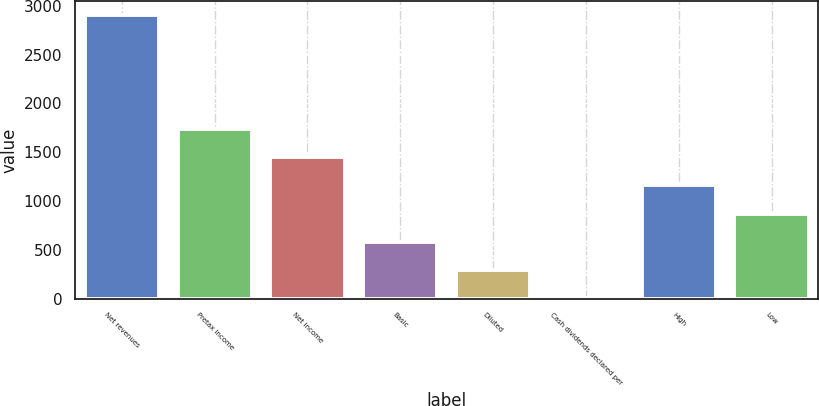Convert chart to OTSL. <chart><loc_0><loc_0><loc_500><loc_500><bar_chart><fcel>Net revenues<fcel>Pretax income<fcel>Net income<fcel>Basic<fcel>Diluted<fcel>Cash dividends declared per<fcel>High<fcel>Low<nl><fcel>2901<fcel>1740.92<fcel>1450.89<fcel>580.81<fcel>290.78<fcel>0.75<fcel>1160.87<fcel>870.84<nl></chart> 